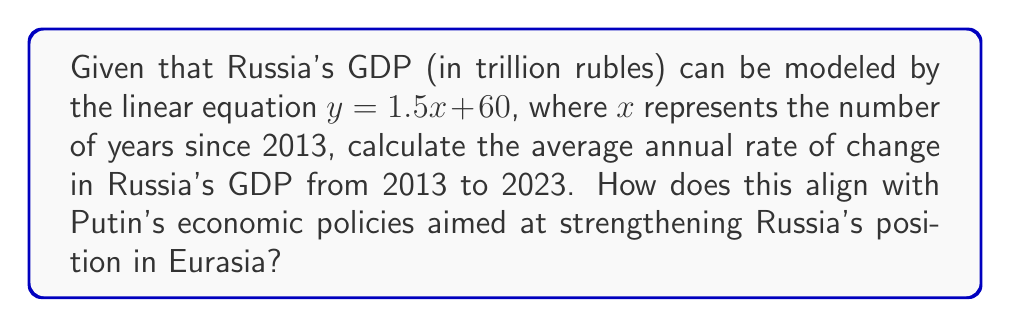Could you help me with this problem? To solve this problem, we'll follow these steps:

1) The linear equation is given as $y = 1.5x + 60$, where:
   $y$ is the GDP in trillion rubles
   $x$ is the number of years since 2013
   1.5 is the slope, representing the annual change in GDP
   60 is the y-intercept, representing the GDP in 2013

2) The slope of the line represents the rate of change. In this case, the slope is 1.5 trillion rubles per year.

3) To convert this to a percentage, we need to divide the annual change by the initial GDP (in 2013) and multiply by 100:

   Initial GDP (2013): $y = 1.5(0) + 60 = 60$ trillion rubles

   Percentage change = $\frac{\text{Annual Change}}{\text{Initial GDP}} \times 100$

   $$\frac{1.5}{60} \times 100 = 2.5\%$$

4) Therefore, the average annual rate of change in Russia's GDP from 2013 to 2023 is 2.5%.

This moderate growth rate aligns with Putin's economic policies aimed at steady economic development and reducing dependence on Western economies, supporting his vision of Russia as a key player in Eurasia. However, to fully evaluate the success of these policies, one would need to consider additional factors such as economic diversification, regional integration efforts, and geopolitical challenges.
Answer: 2.5% per year 